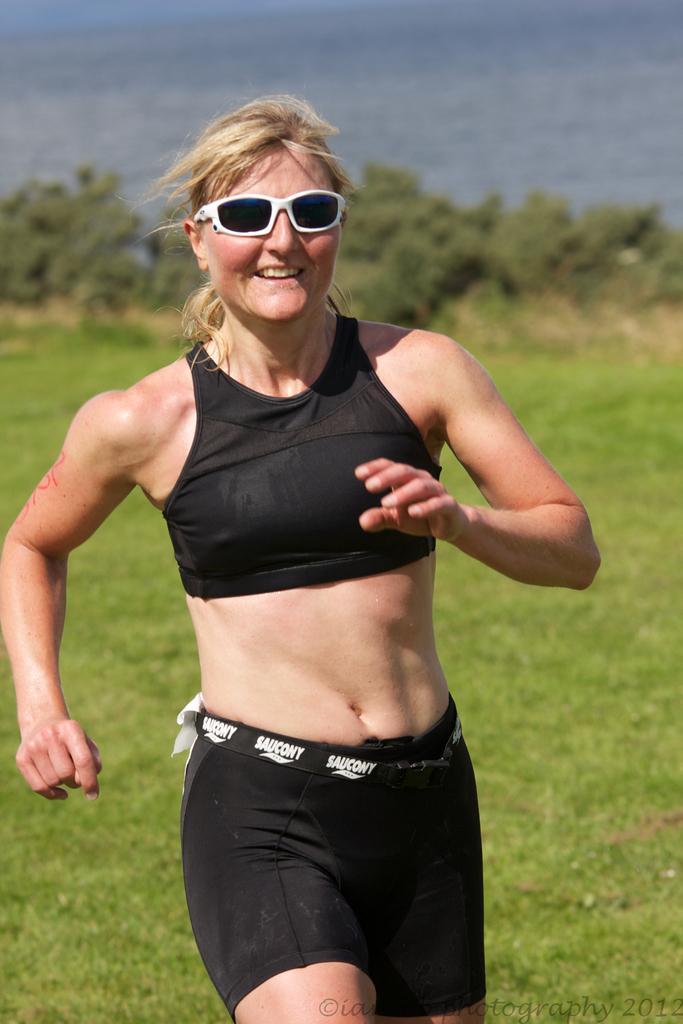Please provide a concise description of this image. In the middle of this image, there is a woman in a black color dress, wearing sunglasses, smiling and running. In the background, there are trees and grass on the ground and there is sky. 